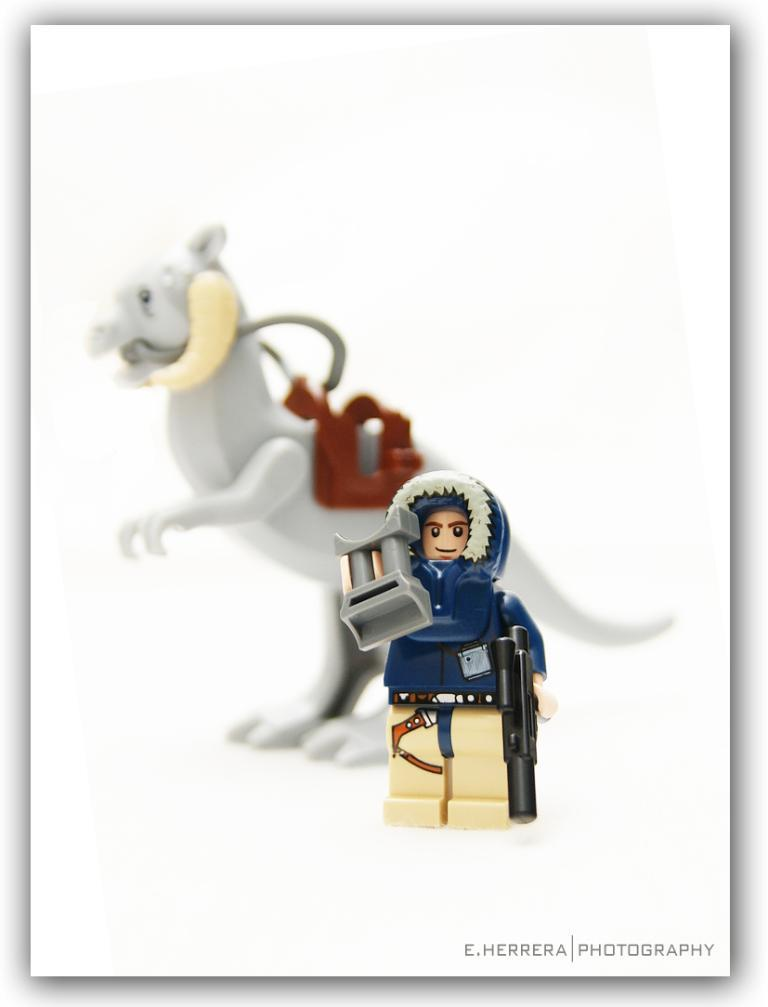How was the image altered or modified? The image is edited. What type of objects can be seen in the image? There are toys in the image. Where are the toys located in the image? The toys are placed on a surface. What type of riddle is being solved by the toys in the image? There is no riddle being solved by the toys in the image, as the toys are inanimate objects and cannot solve riddles. 